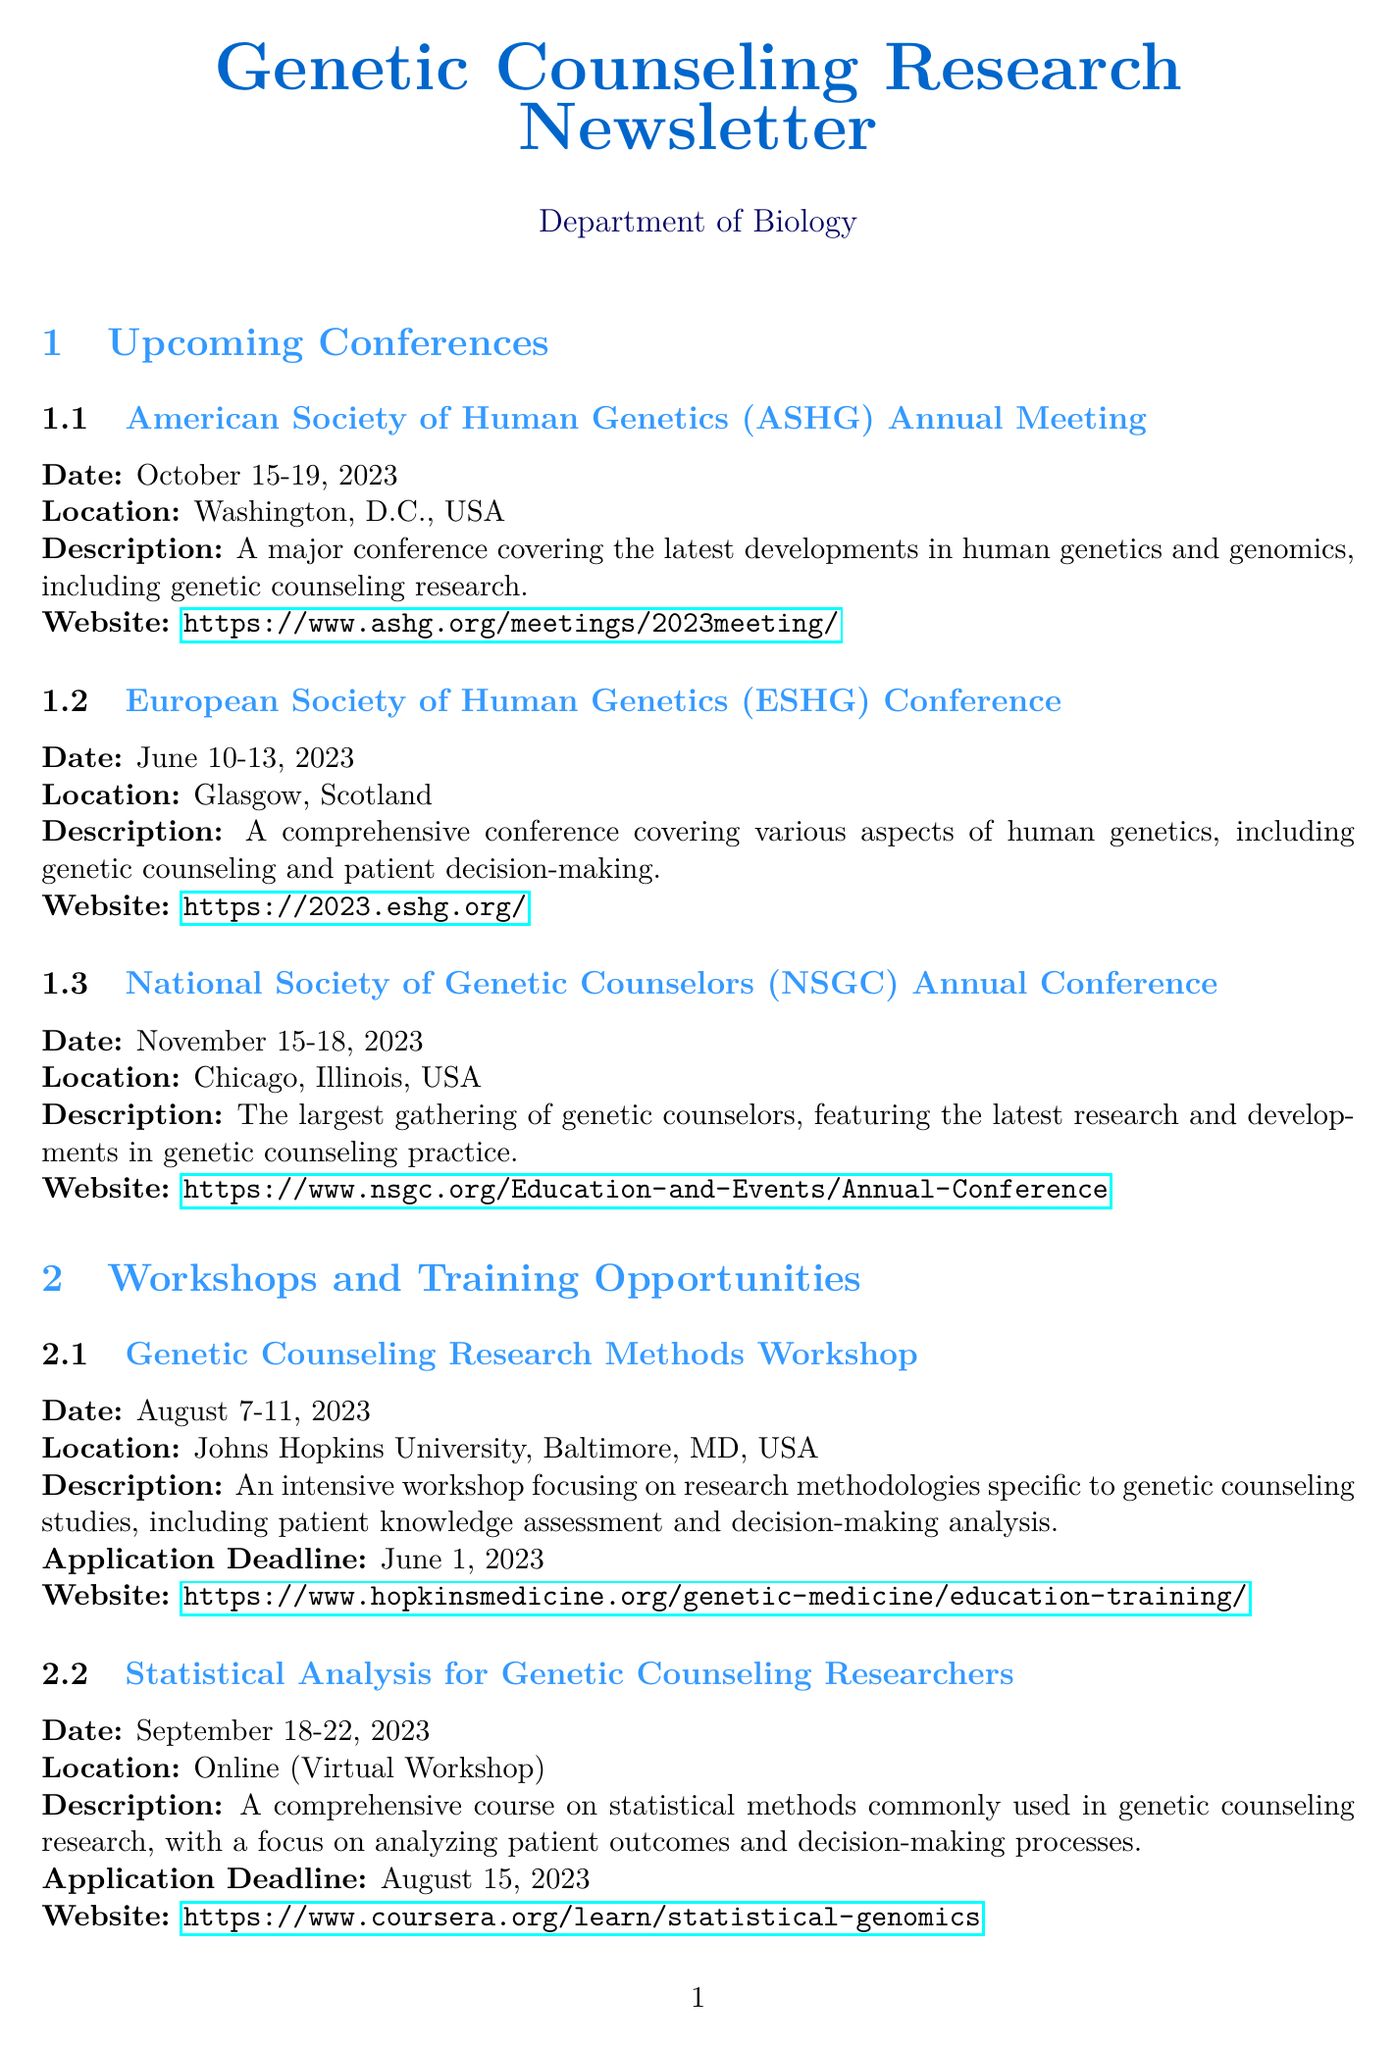What is the date of the American Society of Human Genetics (ASHG) Annual Meeting? The date is provided in the document, which is October 15-19, 2023.
Answer: October 15-19, 2023 Where is the National Society of Genetic Counselors (NSGC) Annual Conference being held? The location is stated in the document as Chicago, Illinois, USA.
Answer: Chicago, Illinois, USA What is the application deadline for the NIH R01 Research Project Grant? The application deadline is specified in the document as October 5, 2023.
Answer: October 5, 2023 Which workshop focuses on statistical methods for genetic counseling research? The document names the workshop "Statistical Analysis for Genetic Counseling Researchers" that covers this topic.
Answer: Statistical Analysis for Genetic Counseling Researchers What is the submission deadline for the Special Issue: Patient-Centered Outcomes in Genetic Counseling? The deadline for submission is mentioned in the document as December 1, 2023.
Answer: December 1, 2023 Which conference covers the latest developments in human genetics and genomics? The American Society of Human Genetics (ASHG) Annual Meeting is highlighted for these topics in the document.
Answer: American Society of Human Genetics (ASHG) Annual Meeting What opportunity is available for early career researchers in genomics? The document mentions the "Genomic Innovator Award (R35)" as an opportunity for early career researchers.
Answer: Genomic Innovator Award (R35) Which journal is seeking original research articles on the impact of genetic counseling? The document specifies the "Journal of Genetic Counseling" is calling for original research articles.
Answer: Journal of Genetic Counseling 